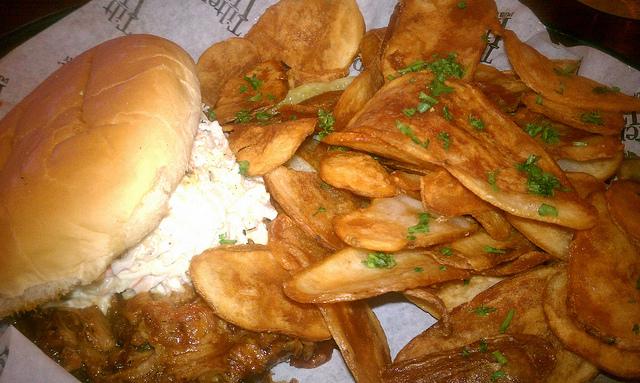Does this person have fries with their meal?
Concise answer only. Yes. What vegetable is this?
Concise answer only. Potato. What color is the banana?
Be succinct. Yellow. What is on the fries?
Short answer required. Parsley. What is the food for?
Concise answer only. Eating. 